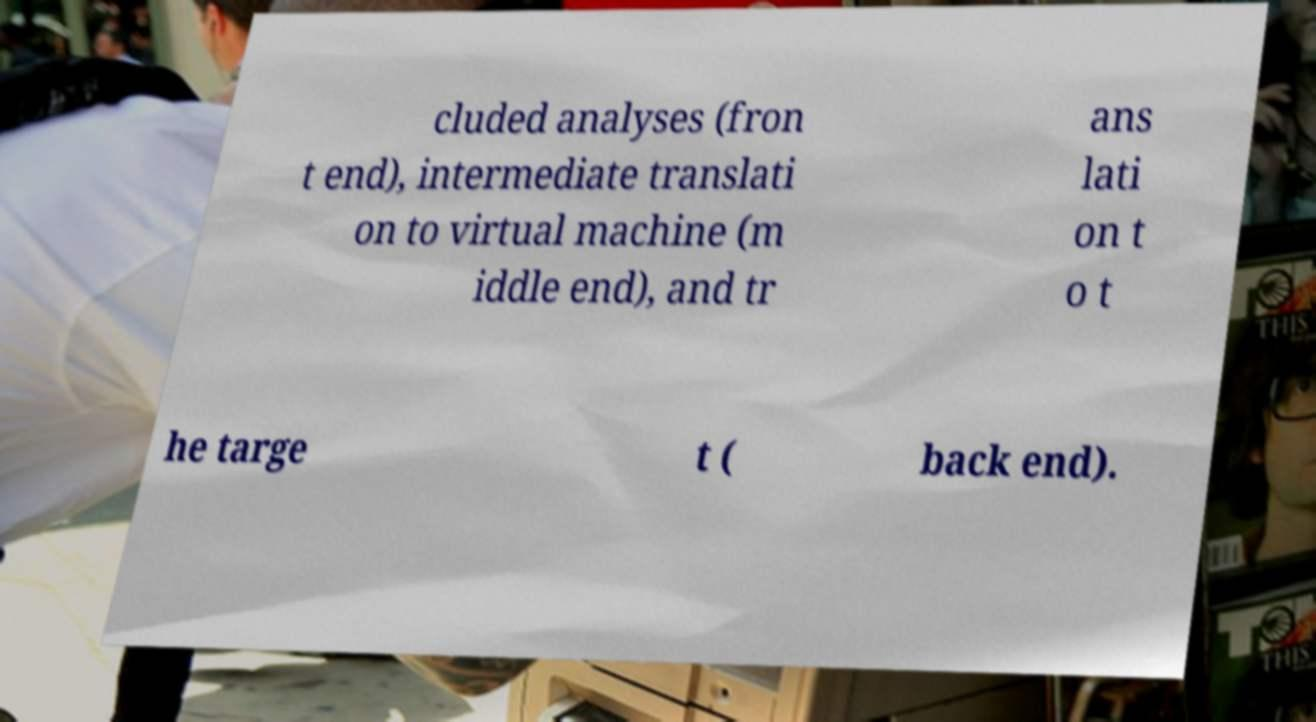Please identify and transcribe the text found in this image. cluded analyses (fron t end), intermediate translati on to virtual machine (m iddle end), and tr ans lati on t o t he targe t ( back end). 